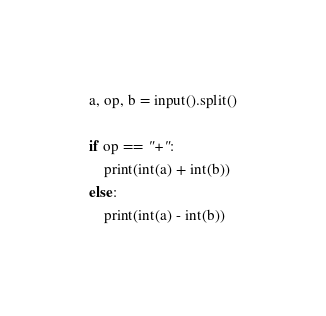<code> <loc_0><loc_0><loc_500><loc_500><_Python_>a, op, b = input().split()

if op == "+":
    print(int(a) + int(b))
else:
    print(int(a) - int(b))</code> 